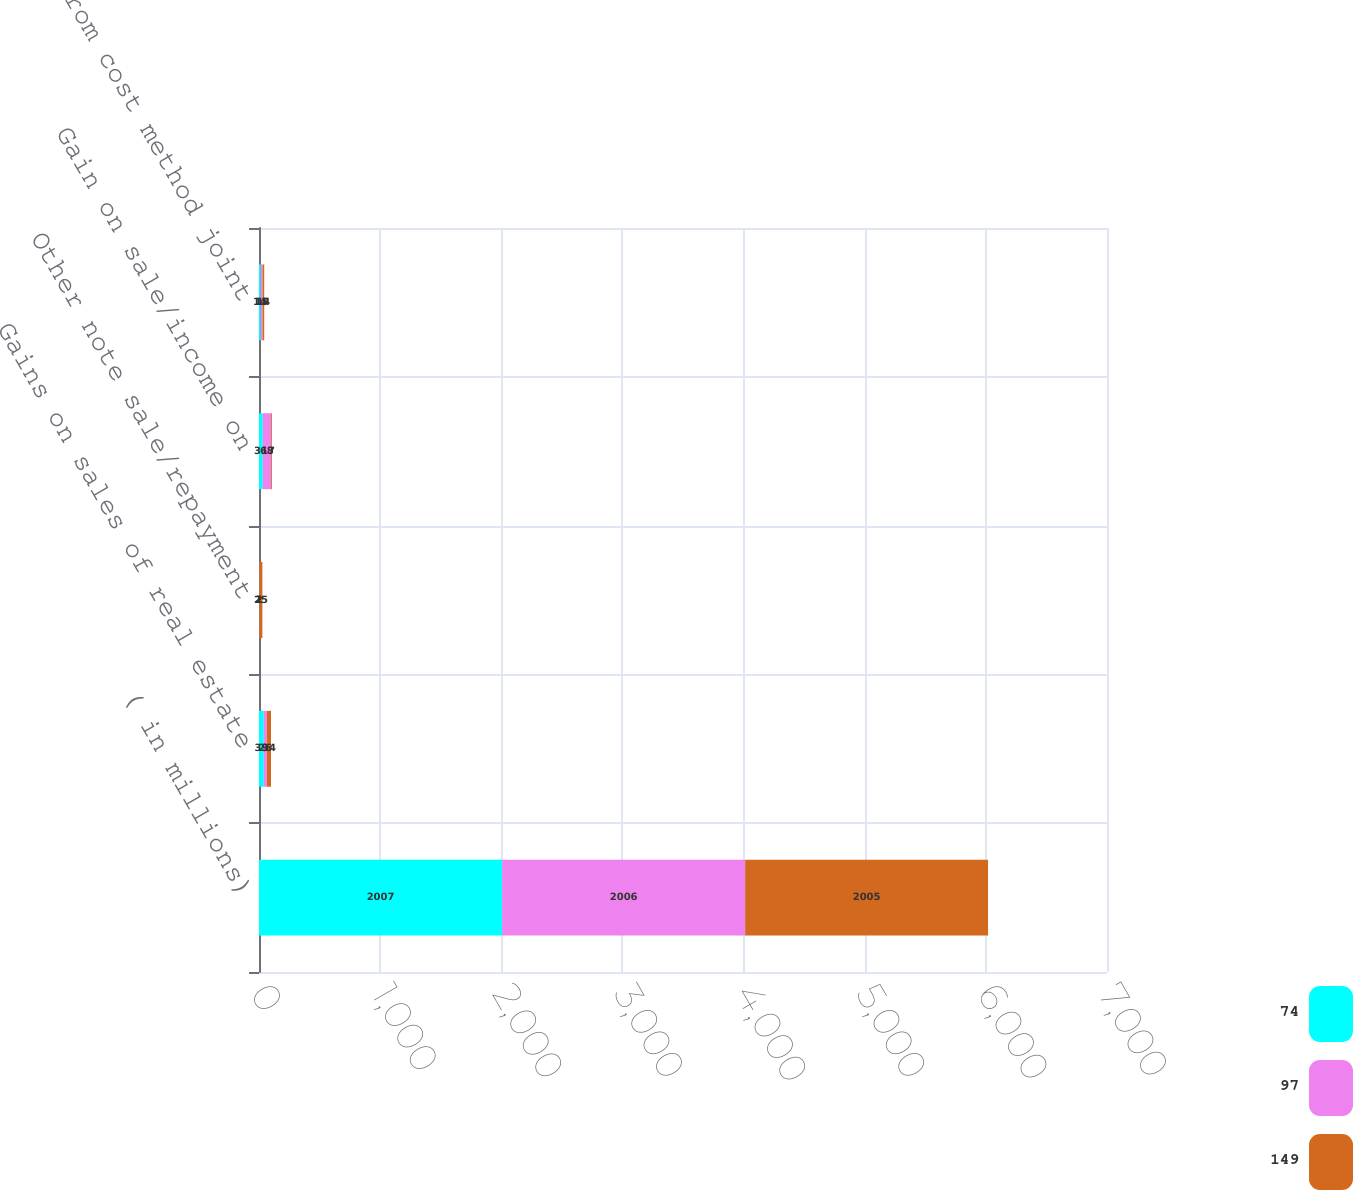Convert chart. <chart><loc_0><loc_0><loc_500><loc_500><stacked_bar_chart><ecel><fcel>( in millions)<fcel>Gains on sales of real estate<fcel>Other note sale/repayment<fcel>Gain on sale/income on<fcel>Income from cost method joint<nl><fcel>74<fcel>2007<fcel>39<fcel>1<fcel>31<fcel>14<nl><fcel>97<fcel>2006<fcel>26<fcel>2<fcel>68<fcel>15<nl><fcel>149<fcel>2005<fcel>34<fcel>25<fcel>7<fcel>14<nl></chart> 